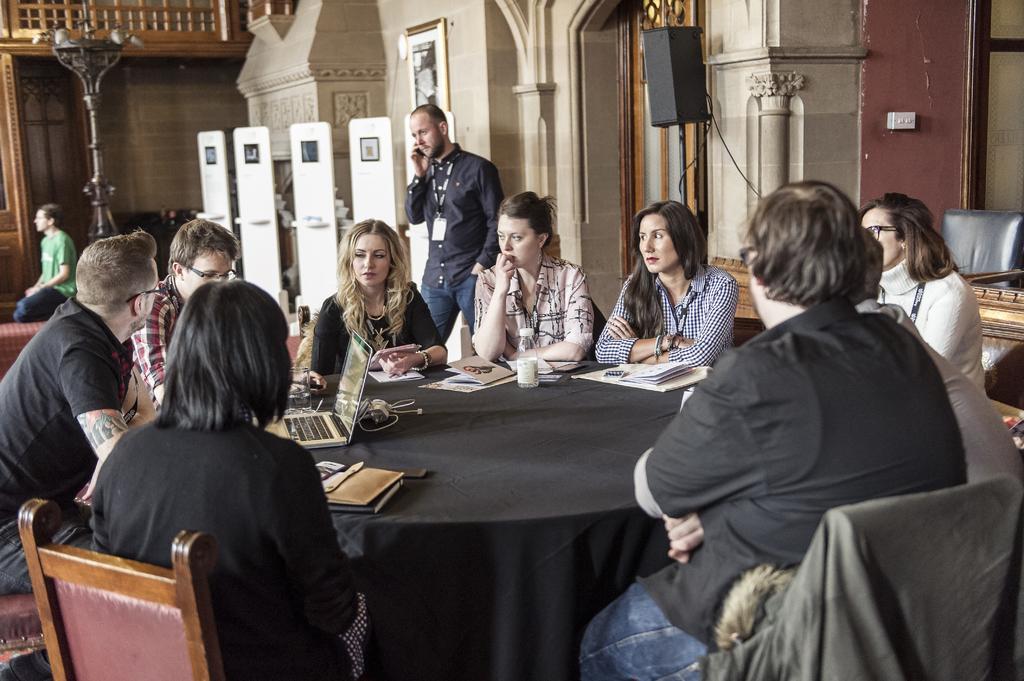Please provide a concise description of this image. In the picture we can find some persons are sitting on the chairs near the table and three persons are looking into the laptop and others are watching them. In the background we can find a man standing and talking in the mobile phone and just beside to him we can find another man sitting and he is wearing a green T-shirt. 